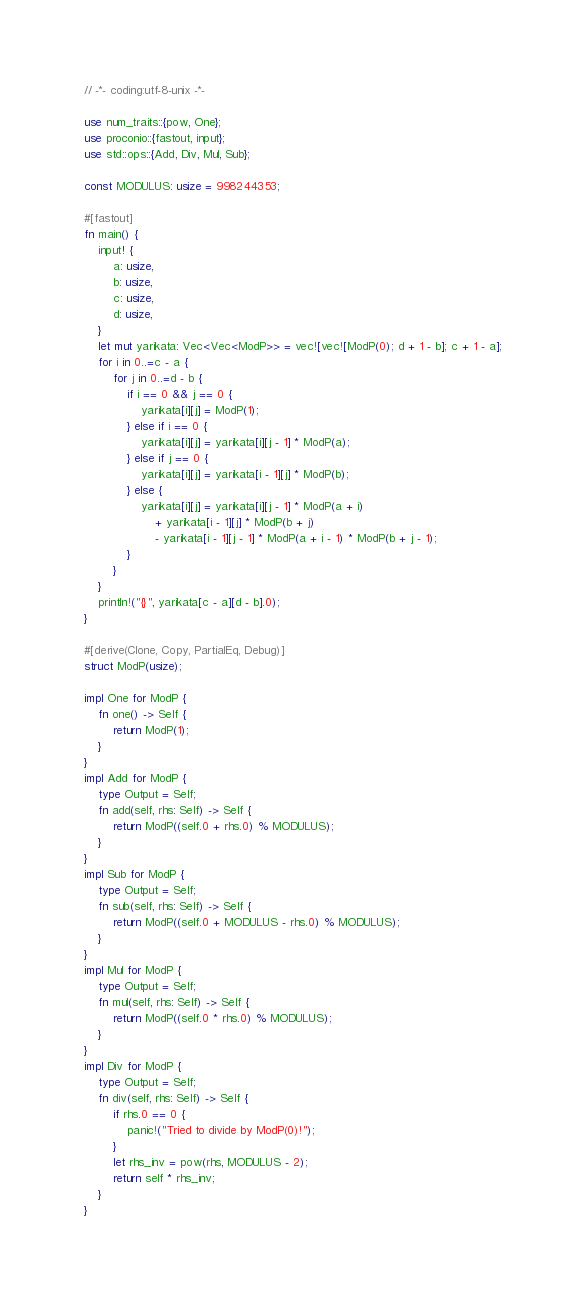Convert code to text. <code><loc_0><loc_0><loc_500><loc_500><_Rust_>// -*- coding:utf-8-unix -*-

use num_traits::{pow, One};
use proconio::{fastout, input};
use std::ops::{Add, Div, Mul, Sub};

const MODULUS: usize = 998244353;

#[fastout]
fn main() {
    input! {
        a: usize,
        b: usize,
        c: usize,
        d: usize,
    }
    let mut yarikata: Vec<Vec<ModP>> = vec![vec![ModP(0); d + 1 - b]; c + 1 - a];
    for i in 0..=c - a {
        for j in 0..=d - b {
            if i == 0 && j == 0 {
                yarikata[i][j] = ModP(1);
            } else if i == 0 {
                yarikata[i][j] = yarikata[i][j - 1] * ModP(a);
            } else if j == 0 {
                yarikata[i][j] = yarikata[i - 1][j] * ModP(b);
            } else {
                yarikata[i][j] = yarikata[i][j - 1] * ModP(a + i)
                    + yarikata[i - 1][j] * ModP(b + j)
                    - yarikata[i - 1][j - 1] * ModP(a + i - 1) * ModP(b + j - 1);
            }
        }
    }
    println!("{}", yarikata[c - a][d - b].0);
}

#[derive(Clone, Copy, PartialEq, Debug)]
struct ModP(usize);

impl One for ModP {
    fn one() -> Self {
        return ModP(1);
    }
}
impl Add for ModP {
    type Output = Self;
    fn add(self, rhs: Self) -> Self {
        return ModP((self.0 + rhs.0) % MODULUS);
    }
}
impl Sub for ModP {
    type Output = Self;
    fn sub(self, rhs: Self) -> Self {
        return ModP((self.0 + MODULUS - rhs.0) % MODULUS);
    }
}
impl Mul for ModP {
    type Output = Self;
    fn mul(self, rhs: Self) -> Self {
        return ModP((self.0 * rhs.0) % MODULUS);
    }
}
impl Div for ModP {
    type Output = Self;
    fn div(self, rhs: Self) -> Self {
        if rhs.0 == 0 {
            panic!("Tried to divide by ModP(0)!");
        }
        let rhs_inv = pow(rhs, MODULUS - 2);
        return self * rhs_inv;
    }
}
</code> 